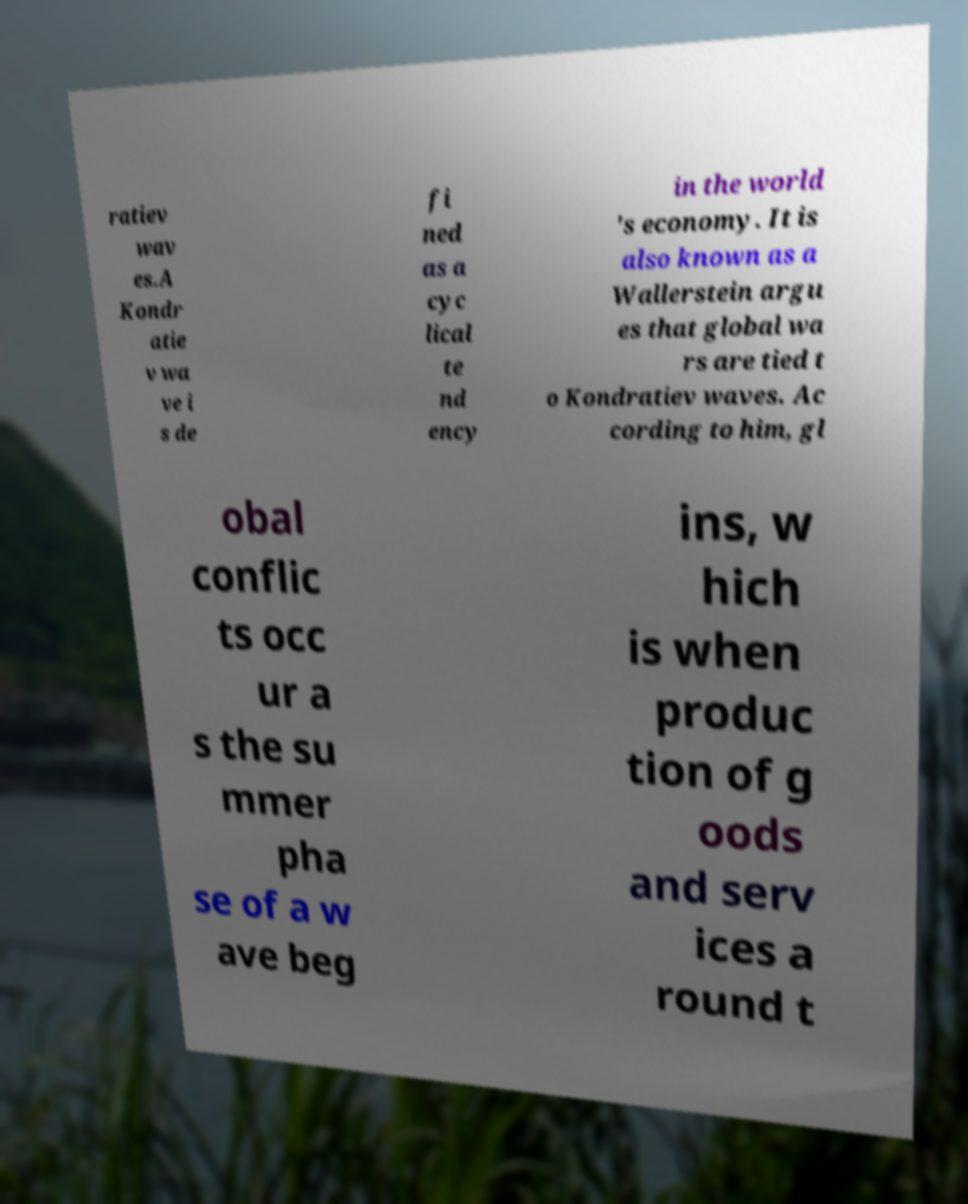Please identify and transcribe the text found in this image. ratiev wav es.A Kondr atie v wa ve i s de fi ned as a cyc lical te nd ency in the world 's economy. It is also known as a Wallerstein argu es that global wa rs are tied t o Kondratiev waves. Ac cording to him, gl obal conflic ts occ ur a s the su mmer pha se of a w ave beg ins, w hich is when produc tion of g oods and serv ices a round t 